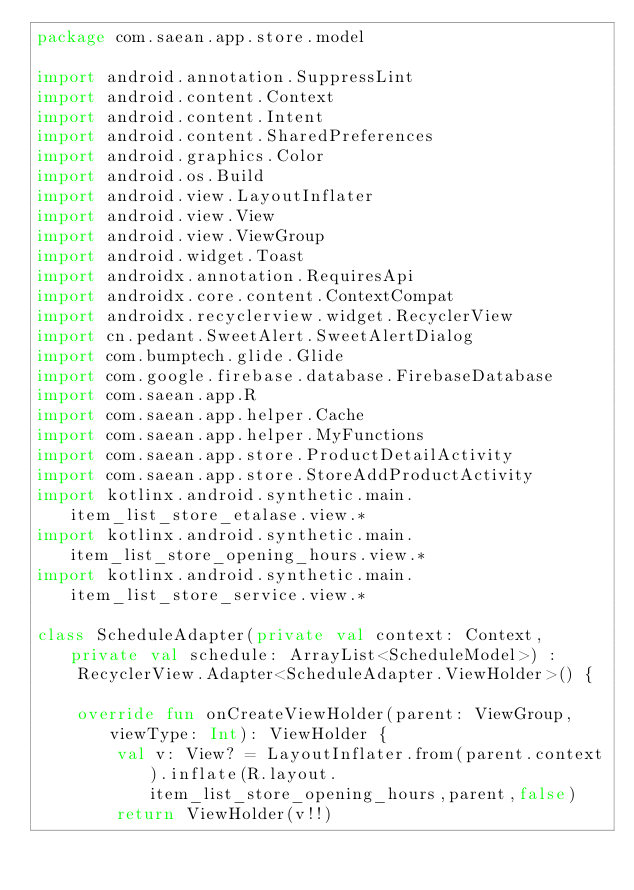<code> <loc_0><loc_0><loc_500><loc_500><_Kotlin_>package com.saean.app.store.model

import android.annotation.SuppressLint
import android.content.Context
import android.content.Intent
import android.content.SharedPreferences
import android.graphics.Color
import android.os.Build
import android.view.LayoutInflater
import android.view.View
import android.view.ViewGroup
import android.widget.Toast
import androidx.annotation.RequiresApi
import androidx.core.content.ContextCompat
import androidx.recyclerview.widget.RecyclerView
import cn.pedant.SweetAlert.SweetAlertDialog
import com.bumptech.glide.Glide
import com.google.firebase.database.FirebaseDatabase
import com.saean.app.R
import com.saean.app.helper.Cache
import com.saean.app.helper.MyFunctions
import com.saean.app.store.ProductDetailActivity
import com.saean.app.store.StoreAddProductActivity
import kotlinx.android.synthetic.main.item_list_store_etalase.view.*
import kotlinx.android.synthetic.main.item_list_store_opening_hours.view.*
import kotlinx.android.synthetic.main.item_list_store_service.view.*

class ScheduleAdapter(private val context: Context, private val schedule: ArrayList<ScheduleModel>) :
    RecyclerView.Adapter<ScheduleAdapter.ViewHolder>() {

    override fun onCreateViewHolder(parent: ViewGroup, viewType: Int): ViewHolder {
        val v: View? = LayoutInflater.from(parent.context).inflate(R.layout.item_list_store_opening_hours,parent,false)
        return ViewHolder(v!!)</code> 